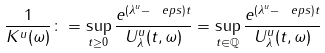<formula> <loc_0><loc_0><loc_500><loc_500>\frac { 1 } { K ^ { u } ( \omega ) } \colon = \sup _ { t \geq 0 } \frac { e ^ { ( \lambda ^ { u } - \ e p s ) t } } { \| U _ { \lambda } ^ { u } ( t , \omega ) \| } = \sup _ { t \in \mathbb { Q } } \frac { e ^ { ( \lambda ^ { u } - \ e p s ) t } } { \| U _ { \lambda } ^ { u } ( t , \omega ) \| }</formula> 